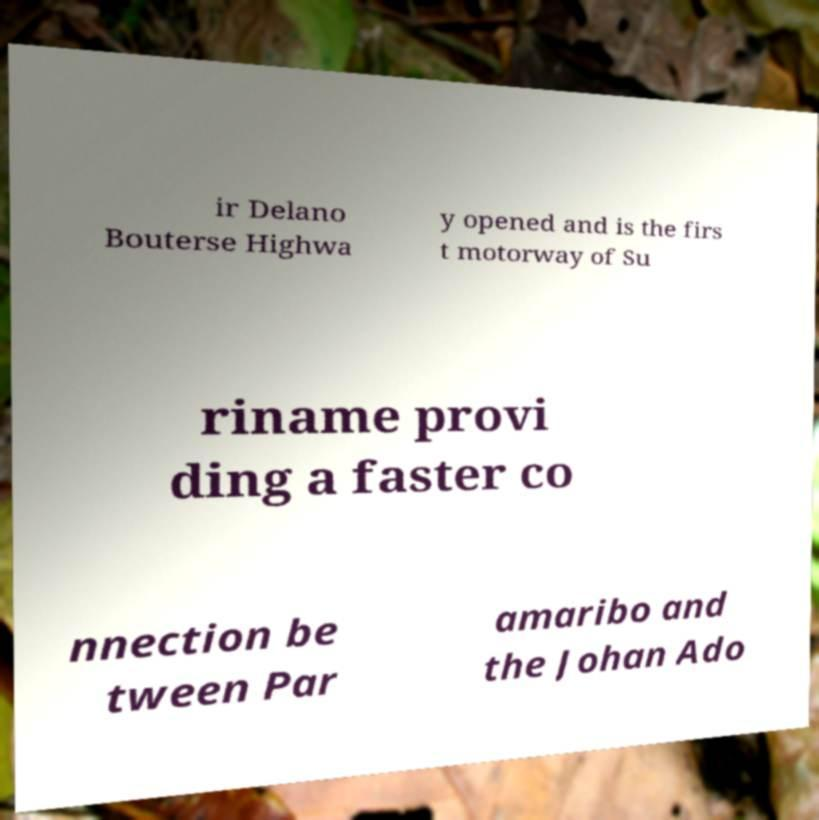Could you assist in decoding the text presented in this image and type it out clearly? ir Delano Bouterse Highwa y opened and is the firs t motorway of Su riname provi ding a faster co nnection be tween Par amaribo and the Johan Ado 